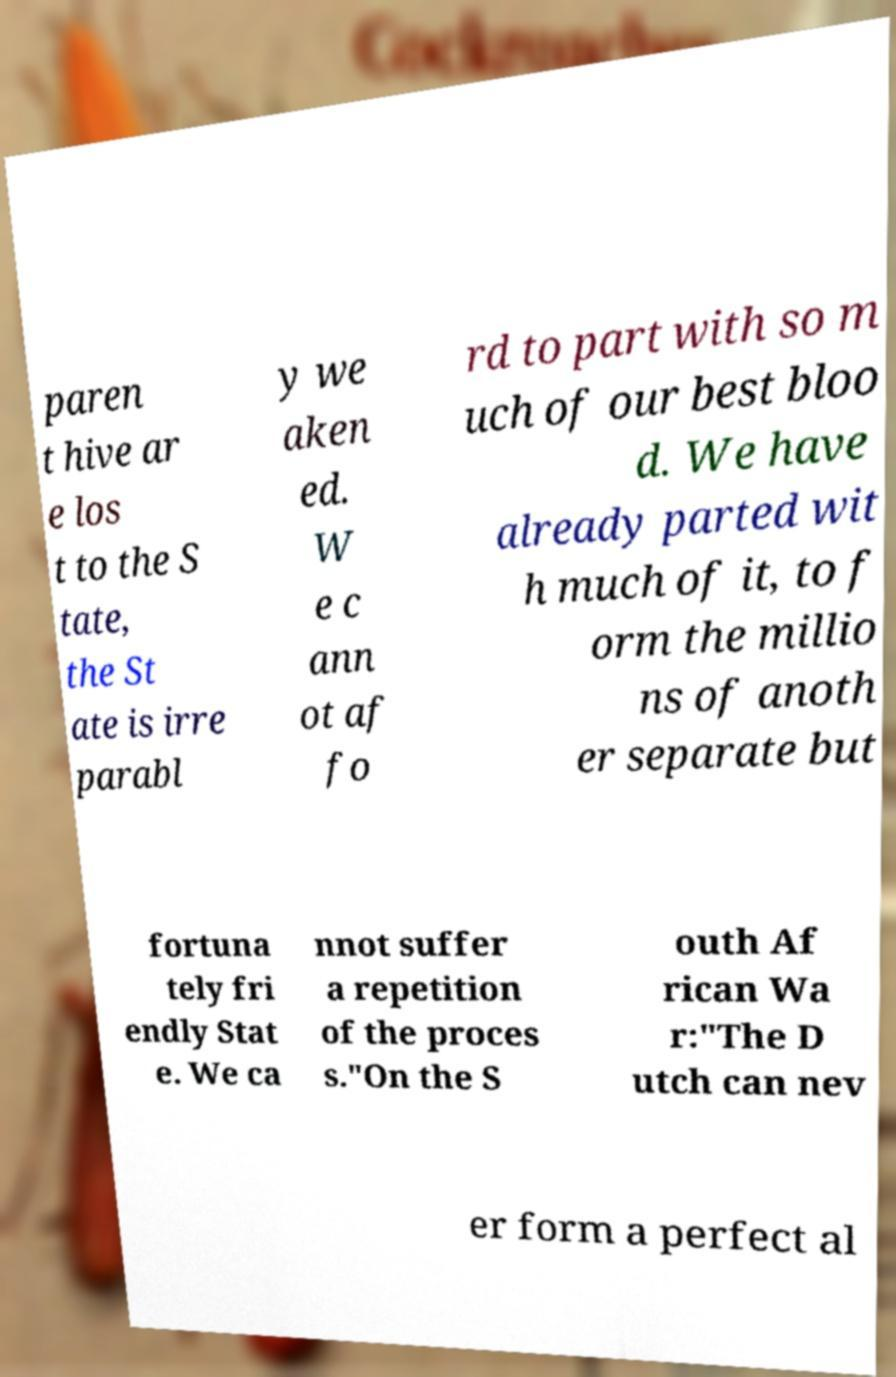What messages or text are displayed in this image? I need them in a readable, typed format. paren t hive ar e los t to the S tate, the St ate is irre parabl y we aken ed. W e c ann ot af fo rd to part with so m uch of our best bloo d. We have already parted wit h much of it, to f orm the millio ns of anoth er separate but fortuna tely fri endly Stat e. We ca nnot suffer a repetition of the proces s."On the S outh Af rican Wa r:"The D utch can nev er form a perfect al 